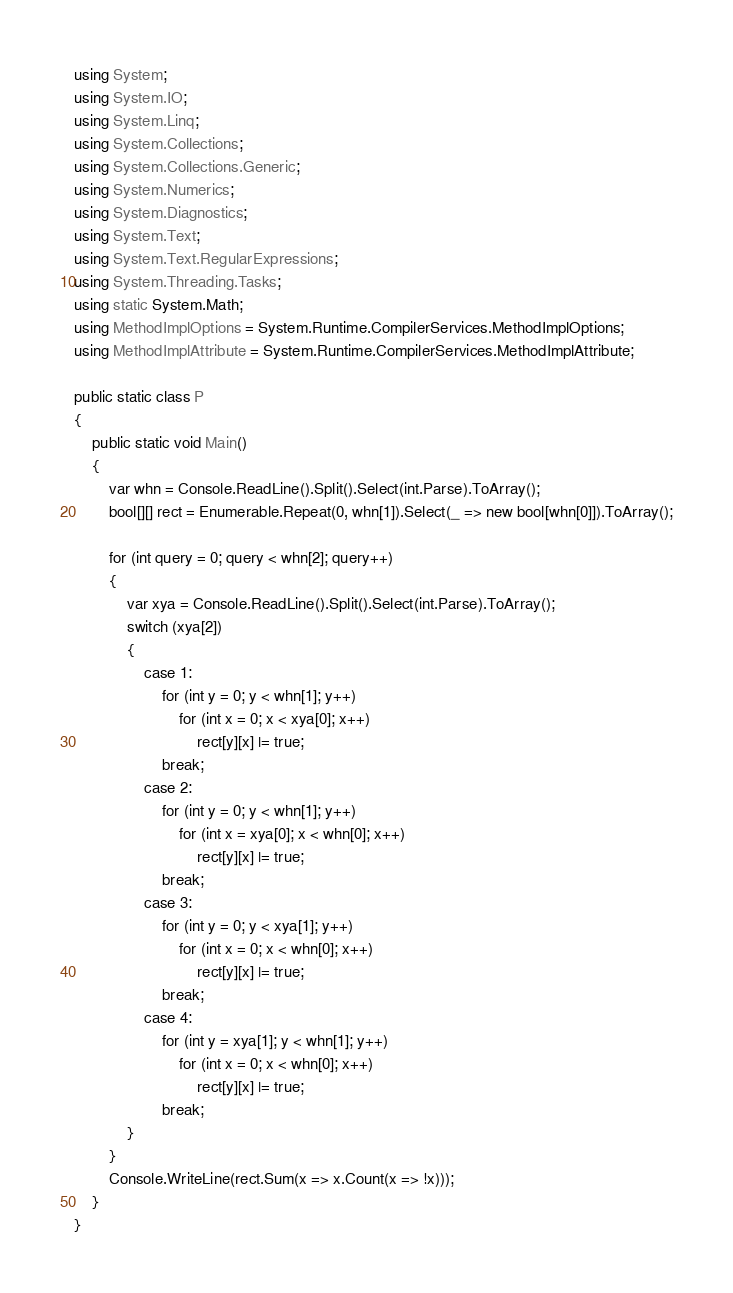Convert code to text. <code><loc_0><loc_0><loc_500><loc_500><_C#_>using System;
using System.IO;
using System.Linq;
using System.Collections;
using System.Collections.Generic;
using System.Numerics;
using System.Diagnostics;
using System.Text;
using System.Text.RegularExpressions;
using System.Threading.Tasks;
using static System.Math;
using MethodImplOptions = System.Runtime.CompilerServices.MethodImplOptions;
using MethodImplAttribute = System.Runtime.CompilerServices.MethodImplAttribute;

public static class P
{
    public static void Main()
    {
        var whn = Console.ReadLine().Split().Select(int.Parse).ToArray();
        bool[][] rect = Enumerable.Repeat(0, whn[1]).Select(_ => new bool[whn[0]]).ToArray();

        for (int query = 0; query < whn[2]; query++)
        {
            var xya = Console.ReadLine().Split().Select(int.Parse).ToArray();
            switch (xya[2])
            {
                case 1:
                    for (int y = 0; y < whn[1]; y++)
                        for (int x = 0; x < xya[0]; x++)
                            rect[y][x] |= true;                        
                    break;
                case 2:
                    for (int y = 0; y < whn[1]; y++)
                        for (int x = xya[0]; x < whn[0]; x++)
                            rect[y][x] |= true;
                    break;
                case 3:
                    for (int y = 0; y < xya[1]; y++)
                        for (int x = 0; x < whn[0]; x++)
                            rect[y][x] |= true;
                    break;
                case 4:
                    for (int y = xya[1]; y < whn[1]; y++)
                        for (int x = 0; x < whn[0]; x++)
                            rect[y][x] |= true;
                    break;
            }
        }
        Console.WriteLine(rect.Sum(x => x.Count(x => !x)));
    }
}
</code> 